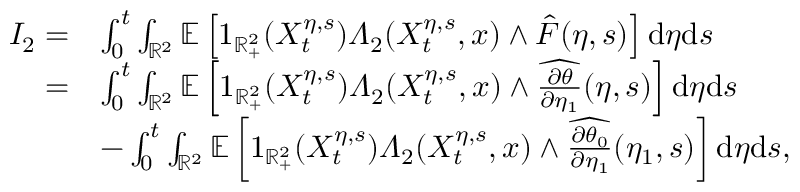<formula> <loc_0><loc_0><loc_500><loc_500>\begin{array} { r l } { I _ { 2 } = } & { \int _ { 0 } ^ { t } \int _ { \mathbb { R } ^ { 2 } } \mathbb { E } \left [ 1 _ { \mathbb { R } _ { + } ^ { 2 } } ( X _ { t } ^ { \eta , s } ) \varLambda _ { 2 } ( X _ { t } ^ { \eta , s } , x ) \wedge \hat { F } ( \eta , s ) \right ] d \eta d s } \\ { = } & { \int _ { 0 } ^ { t } \int _ { \mathbb { R } ^ { 2 } } \mathbb { E } \left [ 1 _ { \mathbb { R } _ { + } ^ { 2 } } ( X _ { t } ^ { \eta , s } ) \varLambda _ { 2 } ( X _ { t } ^ { \eta , s } , x ) \wedge \widehat { \frac { \partial \theta } { \partial \eta _ { 1 } } } ( \eta , s ) \right ] d \eta d s } \\ & { - \int _ { 0 } ^ { t } \int _ { \mathbb { R } ^ { 2 } } \mathbb { E } \left [ 1 _ { \mathbb { R } _ { + } ^ { 2 } } ( X _ { t } ^ { \eta , s } ) \varLambda _ { 2 } ( X _ { t } ^ { \eta , s } , x ) \wedge \widehat { \frac { \partial \theta _ { 0 } } { \partial \eta _ { 1 } } } ( \eta _ { 1 } , s ) \right ] d \eta d s , } \end{array}</formula> 